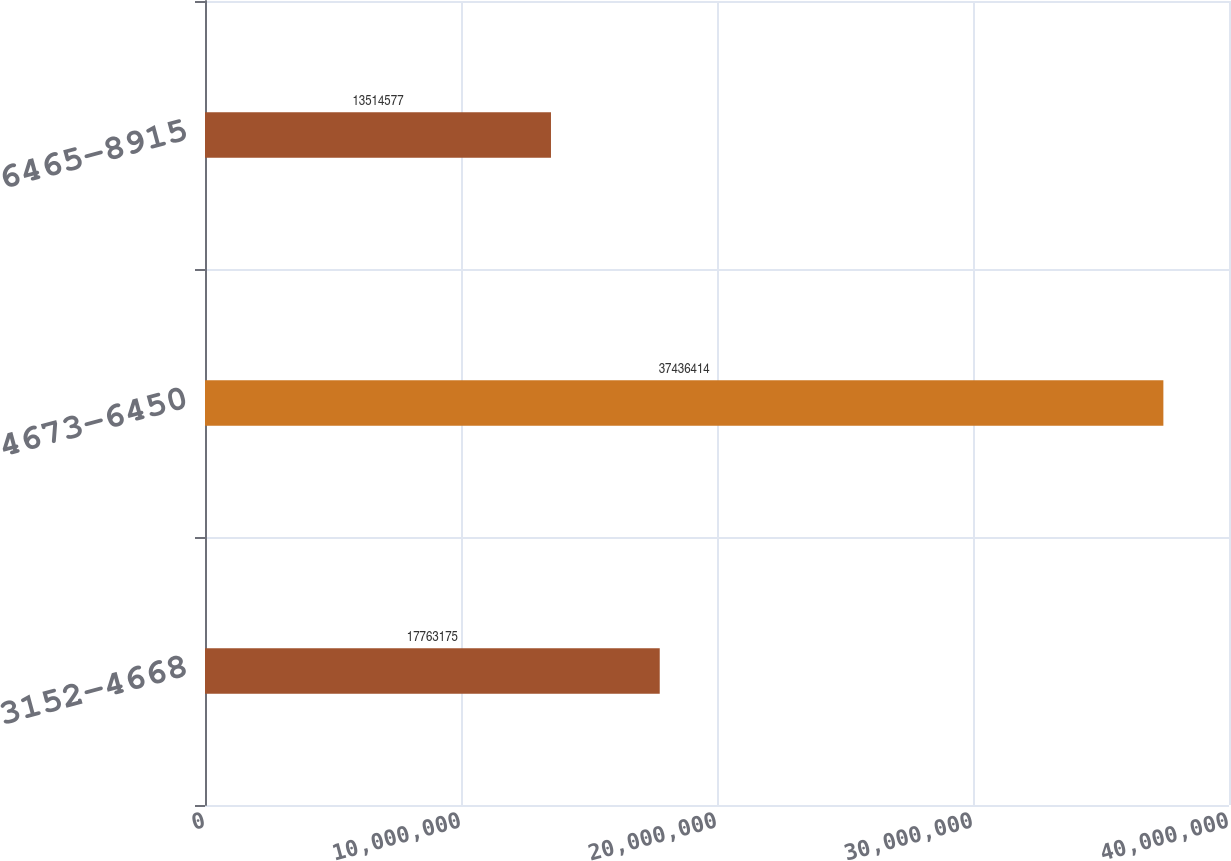<chart> <loc_0><loc_0><loc_500><loc_500><bar_chart><fcel>3152-4668<fcel>4673-6450<fcel>6465-8915<nl><fcel>1.77632e+07<fcel>3.74364e+07<fcel>1.35146e+07<nl></chart> 